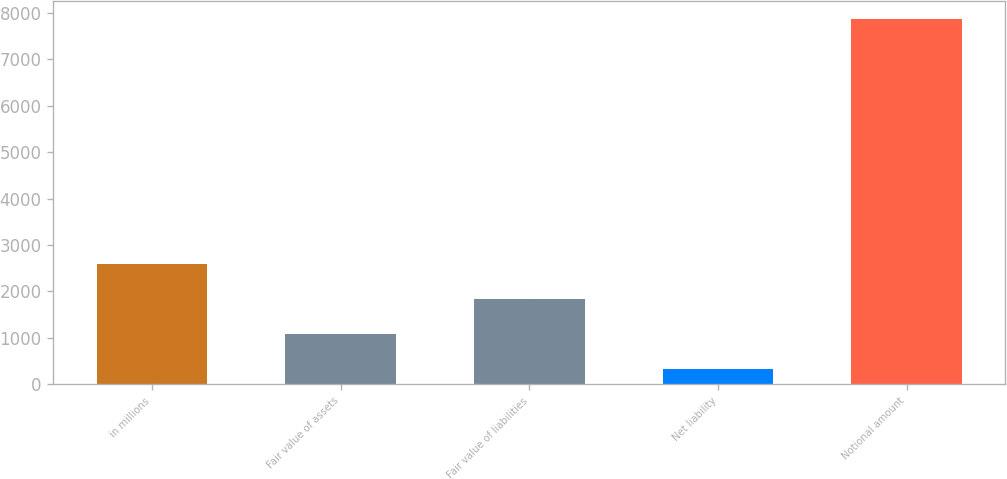<chart> <loc_0><loc_0><loc_500><loc_500><bar_chart><fcel>in millions<fcel>Fair value of assets<fcel>Fair value of liabilities<fcel>Net liability<fcel>Notional amount<nl><fcel>2590.3<fcel>1082.1<fcel>1836.2<fcel>328<fcel>7869<nl></chart> 